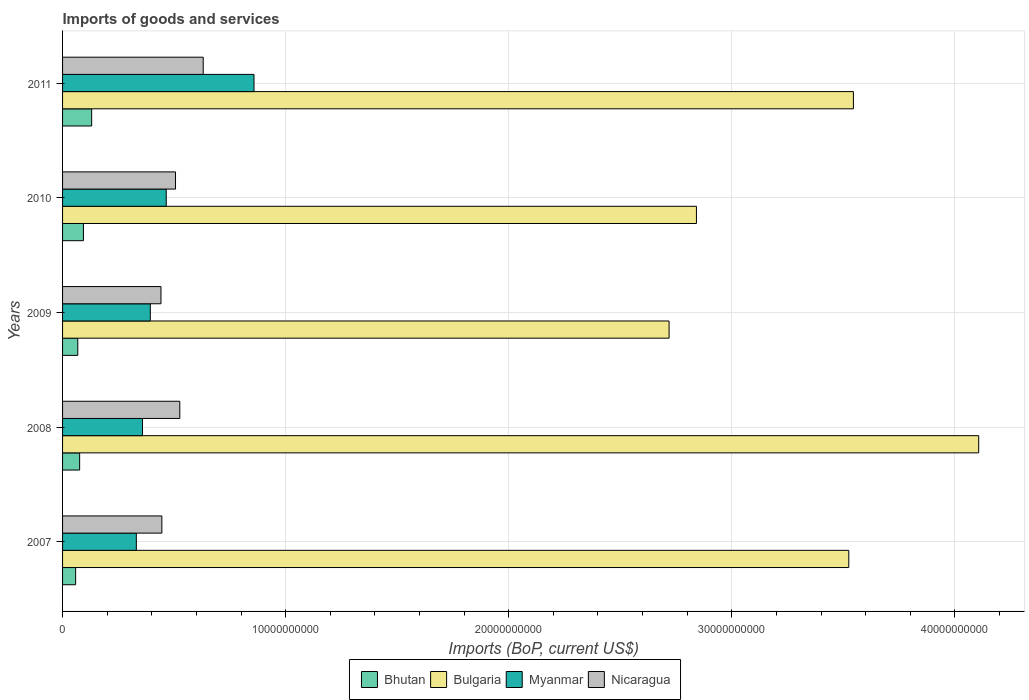Are the number of bars on each tick of the Y-axis equal?
Your response must be concise. Yes. How many bars are there on the 4th tick from the top?
Your response must be concise. 4. How many bars are there on the 5th tick from the bottom?
Your response must be concise. 4. What is the label of the 3rd group of bars from the top?
Your answer should be very brief. 2009. In how many cases, is the number of bars for a given year not equal to the number of legend labels?
Ensure brevity in your answer.  0. What is the amount spent on imports in Myanmar in 2009?
Ensure brevity in your answer.  3.93e+09. Across all years, what is the maximum amount spent on imports in Myanmar?
Your answer should be very brief. 8.58e+09. Across all years, what is the minimum amount spent on imports in Myanmar?
Keep it short and to the point. 3.31e+09. In which year was the amount spent on imports in Bhutan maximum?
Ensure brevity in your answer.  2011. What is the total amount spent on imports in Bhutan in the graph?
Give a very brief answer. 4.27e+09. What is the difference between the amount spent on imports in Bulgaria in 2007 and that in 2011?
Give a very brief answer. -2.08e+08. What is the difference between the amount spent on imports in Myanmar in 2010 and the amount spent on imports in Bhutan in 2011?
Your answer should be very brief. 3.34e+09. What is the average amount spent on imports in Bhutan per year?
Ensure brevity in your answer.  8.55e+08. In the year 2010, what is the difference between the amount spent on imports in Bulgaria and amount spent on imports in Bhutan?
Give a very brief answer. 2.75e+1. What is the ratio of the amount spent on imports in Myanmar in 2008 to that in 2009?
Your answer should be compact. 0.91. Is the amount spent on imports in Nicaragua in 2008 less than that in 2011?
Provide a succinct answer. Yes. Is the difference between the amount spent on imports in Bulgaria in 2009 and 2010 greater than the difference between the amount spent on imports in Bhutan in 2009 and 2010?
Offer a terse response. No. What is the difference between the highest and the second highest amount spent on imports in Myanmar?
Your answer should be very brief. 3.93e+09. What is the difference between the highest and the lowest amount spent on imports in Nicaragua?
Offer a terse response. 1.89e+09. Is it the case that in every year, the sum of the amount spent on imports in Bhutan and amount spent on imports in Bulgaria is greater than the sum of amount spent on imports in Myanmar and amount spent on imports in Nicaragua?
Your response must be concise. Yes. What does the 4th bar from the top in 2009 represents?
Provide a short and direct response. Bhutan. Is it the case that in every year, the sum of the amount spent on imports in Nicaragua and amount spent on imports in Bhutan is greater than the amount spent on imports in Myanmar?
Offer a very short reply. No. How many bars are there?
Your answer should be compact. 20. Are all the bars in the graph horizontal?
Your answer should be compact. Yes. How many years are there in the graph?
Make the answer very short. 5. Are the values on the major ticks of X-axis written in scientific E-notation?
Provide a short and direct response. No. What is the title of the graph?
Make the answer very short. Imports of goods and services. Does "Algeria" appear as one of the legend labels in the graph?
Your response must be concise. No. What is the label or title of the X-axis?
Provide a short and direct response. Imports (BoP, current US$). What is the Imports (BoP, current US$) of Bhutan in 2007?
Your response must be concise. 5.86e+08. What is the Imports (BoP, current US$) of Bulgaria in 2007?
Provide a succinct answer. 3.52e+1. What is the Imports (BoP, current US$) in Myanmar in 2007?
Give a very brief answer. 3.31e+09. What is the Imports (BoP, current US$) in Nicaragua in 2007?
Your answer should be very brief. 4.45e+09. What is the Imports (BoP, current US$) of Bhutan in 2008?
Give a very brief answer. 7.66e+08. What is the Imports (BoP, current US$) of Bulgaria in 2008?
Your answer should be compact. 4.11e+1. What is the Imports (BoP, current US$) of Myanmar in 2008?
Provide a succinct answer. 3.58e+09. What is the Imports (BoP, current US$) of Nicaragua in 2008?
Your answer should be very brief. 5.26e+09. What is the Imports (BoP, current US$) in Bhutan in 2009?
Your response must be concise. 6.82e+08. What is the Imports (BoP, current US$) in Bulgaria in 2009?
Offer a very short reply. 2.72e+1. What is the Imports (BoP, current US$) in Myanmar in 2009?
Give a very brief answer. 3.93e+09. What is the Imports (BoP, current US$) of Nicaragua in 2009?
Make the answer very short. 4.41e+09. What is the Imports (BoP, current US$) in Bhutan in 2010?
Offer a very short reply. 9.35e+08. What is the Imports (BoP, current US$) of Bulgaria in 2010?
Give a very brief answer. 2.84e+1. What is the Imports (BoP, current US$) of Myanmar in 2010?
Keep it short and to the point. 4.65e+09. What is the Imports (BoP, current US$) in Nicaragua in 2010?
Your answer should be compact. 5.06e+09. What is the Imports (BoP, current US$) of Bhutan in 2011?
Provide a short and direct response. 1.30e+09. What is the Imports (BoP, current US$) in Bulgaria in 2011?
Your answer should be very brief. 3.55e+1. What is the Imports (BoP, current US$) in Myanmar in 2011?
Offer a terse response. 8.58e+09. What is the Imports (BoP, current US$) in Nicaragua in 2011?
Your answer should be compact. 6.30e+09. Across all years, what is the maximum Imports (BoP, current US$) in Bhutan?
Keep it short and to the point. 1.30e+09. Across all years, what is the maximum Imports (BoP, current US$) of Bulgaria?
Your answer should be compact. 4.11e+1. Across all years, what is the maximum Imports (BoP, current US$) of Myanmar?
Your response must be concise. 8.58e+09. Across all years, what is the maximum Imports (BoP, current US$) of Nicaragua?
Your response must be concise. 6.30e+09. Across all years, what is the minimum Imports (BoP, current US$) in Bhutan?
Make the answer very short. 5.86e+08. Across all years, what is the minimum Imports (BoP, current US$) in Bulgaria?
Ensure brevity in your answer.  2.72e+1. Across all years, what is the minimum Imports (BoP, current US$) of Myanmar?
Provide a short and direct response. 3.31e+09. Across all years, what is the minimum Imports (BoP, current US$) of Nicaragua?
Offer a terse response. 4.41e+09. What is the total Imports (BoP, current US$) in Bhutan in the graph?
Provide a short and direct response. 4.27e+09. What is the total Imports (BoP, current US$) in Bulgaria in the graph?
Provide a short and direct response. 1.67e+11. What is the total Imports (BoP, current US$) in Myanmar in the graph?
Ensure brevity in your answer.  2.40e+1. What is the total Imports (BoP, current US$) of Nicaragua in the graph?
Your response must be concise. 2.55e+1. What is the difference between the Imports (BoP, current US$) in Bhutan in 2007 and that in 2008?
Provide a succinct answer. -1.79e+08. What is the difference between the Imports (BoP, current US$) of Bulgaria in 2007 and that in 2008?
Your response must be concise. -5.82e+09. What is the difference between the Imports (BoP, current US$) of Myanmar in 2007 and that in 2008?
Your answer should be very brief. -2.76e+08. What is the difference between the Imports (BoP, current US$) in Nicaragua in 2007 and that in 2008?
Make the answer very short. -8.05e+08. What is the difference between the Imports (BoP, current US$) of Bhutan in 2007 and that in 2009?
Offer a very short reply. -9.58e+07. What is the difference between the Imports (BoP, current US$) in Bulgaria in 2007 and that in 2009?
Provide a succinct answer. 8.06e+09. What is the difference between the Imports (BoP, current US$) in Myanmar in 2007 and that in 2009?
Keep it short and to the point. -6.26e+08. What is the difference between the Imports (BoP, current US$) of Nicaragua in 2007 and that in 2009?
Your answer should be compact. 3.97e+07. What is the difference between the Imports (BoP, current US$) in Bhutan in 2007 and that in 2010?
Ensure brevity in your answer.  -3.49e+08. What is the difference between the Imports (BoP, current US$) of Bulgaria in 2007 and that in 2010?
Your response must be concise. 6.83e+09. What is the difference between the Imports (BoP, current US$) of Myanmar in 2007 and that in 2010?
Make the answer very short. -1.34e+09. What is the difference between the Imports (BoP, current US$) in Nicaragua in 2007 and that in 2010?
Give a very brief answer. -6.12e+08. What is the difference between the Imports (BoP, current US$) in Bhutan in 2007 and that in 2011?
Offer a very short reply. -7.18e+08. What is the difference between the Imports (BoP, current US$) in Bulgaria in 2007 and that in 2011?
Make the answer very short. -2.08e+08. What is the difference between the Imports (BoP, current US$) of Myanmar in 2007 and that in 2011?
Your answer should be compact. -5.27e+09. What is the difference between the Imports (BoP, current US$) of Nicaragua in 2007 and that in 2011?
Provide a short and direct response. -1.85e+09. What is the difference between the Imports (BoP, current US$) in Bhutan in 2008 and that in 2009?
Your answer should be compact. 8.35e+07. What is the difference between the Imports (BoP, current US$) in Bulgaria in 2008 and that in 2009?
Your answer should be compact. 1.39e+1. What is the difference between the Imports (BoP, current US$) of Myanmar in 2008 and that in 2009?
Provide a short and direct response. -3.50e+08. What is the difference between the Imports (BoP, current US$) in Nicaragua in 2008 and that in 2009?
Make the answer very short. 8.44e+08. What is the difference between the Imports (BoP, current US$) of Bhutan in 2008 and that in 2010?
Make the answer very short. -1.70e+08. What is the difference between the Imports (BoP, current US$) of Bulgaria in 2008 and that in 2010?
Give a very brief answer. 1.27e+1. What is the difference between the Imports (BoP, current US$) in Myanmar in 2008 and that in 2010?
Your answer should be compact. -1.06e+09. What is the difference between the Imports (BoP, current US$) of Nicaragua in 2008 and that in 2010?
Offer a terse response. 1.92e+08. What is the difference between the Imports (BoP, current US$) of Bhutan in 2008 and that in 2011?
Ensure brevity in your answer.  -5.39e+08. What is the difference between the Imports (BoP, current US$) of Bulgaria in 2008 and that in 2011?
Your response must be concise. 5.61e+09. What is the difference between the Imports (BoP, current US$) in Myanmar in 2008 and that in 2011?
Your answer should be compact. -5.00e+09. What is the difference between the Imports (BoP, current US$) in Nicaragua in 2008 and that in 2011?
Make the answer very short. -1.05e+09. What is the difference between the Imports (BoP, current US$) in Bhutan in 2009 and that in 2010?
Provide a succinct answer. -2.53e+08. What is the difference between the Imports (BoP, current US$) in Bulgaria in 2009 and that in 2010?
Offer a terse response. -1.23e+09. What is the difference between the Imports (BoP, current US$) of Myanmar in 2009 and that in 2010?
Provide a succinct answer. -7.14e+08. What is the difference between the Imports (BoP, current US$) of Nicaragua in 2009 and that in 2010?
Your response must be concise. -6.52e+08. What is the difference between the Imports (BoP, current US$) in Bhutan in 2009 and that in 2011?
Provide a short and direct response. -6.22e+08. What is the difference between the Imports (BoP, current US$) of Bulgaria in 2009 and that in 2011?
Ensure brevity in your answer.  -8.26e+09. What is the difference between the Imports (BoP, current US$) of Myanmar in 2009 and that in 2011?
Provide a short and direct response. -4.65e+09. What is the difference between the Imports (BoP, current US$) of Nicaragua in 2009 and that in 2011?
Keep it short and to the point. -1.89e+09. What is the difference between the Imports (BoP, current US$) of Bhutan in 2010 and that in 2011?
Your answer should be compact. -3.69e+08. What is the difference between the Imports (BoP, current US$) of Bulgaria in 2010 and that in 2011?
Make the answer very short. -7.04e+09. What is the difference between the Imports (BoP, current US$) in Myanmar in 2010 and that in 2011?
Make the answer very short. -3.93e+09. What is the difference between the Imports (BoP, current US$) in Nicaragua in 2010 and that in 2011?
Make the answer very short. -1.24e+09. What is the difference between the Imports (BoP, current US$) in Bhutan in 2007 and the Imports (BoP, current US$) in Bulgaria in 2008?
Offer a very short reply. -4.05e+1. What is the difference between the Imports (BoP, current US$) of Bhutan in 2007 and the Imports (BoP, current US$) of Myanmar in 2008?
Provide a succinct answer. -3.00e+09. What is the difference between the Imports (BoP, current US$) in Bhutan in 2007 and the Imports (BoP, current US$) in Nicaragua in 2008?
Give a very brief answer. -4.67e+09. What is the difference between the Imports (BoP, current US$) of Bulgaria in 2007 and the Imports (BoP, current US$) of Myanmar in 2008?
Your response must be concise. 3.17e+1. What is the difference between the Imports (BoP, current US$) in Bulgaria in 2007 and the Imports (BoP, current US$) in Nicaragua in 2008?
Your answer should be very brief. 3.00e+1. What is the difference between the Imports (BoP, current US$) of Myanmar in 2007 and the Imports (BoP, current US$) of Nicaragua in 2008?
Offer a terse response. -1.95e+09. What is the difference between the Imports (BoP, current US$) of Bhutan in 2007 and the Imports (BoP, current US$) of Bulgaria in 2009?
Ensure brevity in your answer.  -2.66e+1. What is the difference between the Imports (BoP, current US$) of Bhutan in 2007 and the Imports (BoP, current US$) of Myanmar in 2009?
Keep it short and to the point. -3.35e+09. What is the difference between the Imports (BoP, current US$) of Bhutan in 2007 and the Imports (BoP, current US$) of Nicaragua in 2009?
Your answer should be compact. -3.82e+09. What is the difference between the Imports (BoP, current US$) of Bulgaria in 2007 and the Imports (BoP, current US$) of Myanmar in 2009?
Keep it short and to the point. 3.13e+1. What is the difference between the Imports (BoP, current US$) in Bulgaria in 2007 and the Imports (BoP, current US$) in Nicaragua in 2009?
Offer a terse response. 3.08e+1. What is the difference between the Imports (BoP, current US$) in Myanmar in 2007 and the Imports (BoP, current US$) in Nicaragua in 2009?
Your answer should be compact. -1.10e+09. What is the difference between the Imports (BoP, current US$) in Bhutan in 2007 and the Imports (BoP, current US$) in Bulgaria in 2010?
Your answer should be very brief. -2.78e+1. What is the difference between the Imports (BoP, current US$) of Bhutan in 2007 and the Imports (BoP, current US$) of Myanmar in 2010?
Offer a terse response. -4.06e+09. What is the difference between the Imports (BoP, current US$) in Bhutan in 2007 and the Imports (BoP, current US$) in Nicaragua in 2010?
Give a very brief answer. -4.48e+09. What is the difference between the Imports (BoP, current US$) of Bulgaria in 2007 and the Imports (BoP, current US$) of Myanmar in 2010?
Make the answer very short. 3.06e+1. What is the difference between the Imports (BoP, current US$) of Bulgaria in 2007 and the Imports (BoP, current US$) of Nicaragua in 2010?
Offer a very short reply. 3.02e+1. What is the difference between the Imports (BoP, current US$) in Myanmar in 2007 and the Imports (BoP, current US$) in Nicaragua in 2010?
Provide a short and direct response. -1.76e+09. What is the difference between the Imports (BoP, current US$) in Bhutan in 2007 and the Imports (BoP, current US$) in Bulgaria in 2011?
Make the answer very short. -3.49e+1. What is the difference between the Imports (BoP, current US$) in Bhutan in 2007 and the Imports (BoP, current US$) in Myanmar in 2011?
Your answer should be very brief. -7.99e+09. What is the difference between the Imports (BoP, current US$) in Bhutan in 2007 and the Imports (BoP, current US$) in Nicaragua in 2011?
Provide a succinct answer. -5.72e+09. What is the difference between the Imports (BoP, current US$) in Bulgaria in 2007 and the Imports (BoP, current US$) in Myanmar in 2011?
Keep it short and to the point. 2.67e+1. What is the difference between the Imports (BoP, current US$) in Bulgaria in 2007 and the Imports (BoP, current US$) in Nicaragua in 2011?
Provide a short and direct response. 2.89e+1. What is the difference between the Imports (BoP, current US$) of Myanmar in 2007 and the Imports (BoP, current US$) of Nicaragua in 2011?
Provide a succinct answer. -3.00e+09. What is the difference between the Imports (BoP, current US$) in Bhutan in 2008 and the Imports (BoP, current US$) in Bulgaria in 2009?
Provide a short and direct response. -2.64e+1. What is the difference between the Imports (BoP, current US$) of Bhutan in 2008 and the Imports (BoP, current US$) of Myanmar in 2009?
Provide a short and direct response. -3.17e+09. What is the difference between the Imports (BoP, current US$) of Bhutan in 2008 and the Imports (BoP, current US$) of Nicaragua in 2009?
Your answer should be compact. -3.65e+09. What is the difference between the Imports (BoP, current US$) in Bulgaria in 2008 and the Imports (BoP, current US$) in Myanmar in 2009?
Your response must be concise. 3.71e+1. What is the difference between the Imports (BoP, current US$) of Bulgaria in 2008 and the Imports (BoP, current US$) of Nicaragua in 2009?
Make the answer very short. 3.67e+1. What is the difference between the Imports (BoP, current US$) of Myanmar in 2008 and the Imports (BoP, current US$) of Nicaragua in 2009?
Ensure brevity in your answer.  -8.28e+08. What is the difference between the Imports (BoP, current US$) of Bhutan in 2008 and the Imports (BoP, current US$) of Bulgaria in 2010?
Make the answer very short. -2.76e+1. What is the difference between the Imports (BoP, current US$) in Bhutan in 2008 and the Imports (BoP, current US$) in Myanmar in 2010?
Provide a succinct answer. -3.88e+09. What is the difference between the Imports (BoP, current US$) of Bhutan in 2008 and the Imports (BoP, current US$) of Nicaragua in 2010?
Ensure brevity in your answer.  -4.30e+09. What is the difference between the Imports (BoP, current US$) of Bulgaria in 2008 and the Imports (BoP, current US$) of Myanmar in 2010?
Offer a terse response. 3.64e+1. What is the difference between the Imports (BoP, current US$) of Bulgaria in 2008 and the Imports (BoP, current US$) of Nicaragua in 2010?
Keep it short and to the point. 3.60e+1. What is the difference between the Imports (BoP, current US$) in Myanmar in 2008 and the Imports (BoP, current US$) in Nicaragua in 2010?
Your response must be concise. -1.48e+09. What is the difference between the Imports (BoP, current US$) in Bhutan in 2008 and the Imports (BoP, current US$) in Bulgaria in 2011?
Give a very brief answer. -3.47e+1. What is the difference between the Imports (BoP, current US$) of Bhutan in 2008 and the Imports (BoP, current US$) of Myanmar in 2011?
Offer a terse response. -7.82e+09. What is the difference between the Imports (BoP, current US$) in Bhutan in 2008 and the Imports (BoP, current US$) in Nicaragua in 2011?
Your response must be concise. -5.54e+09. What is the difference between the Imports (BoP, current US$) in Bulgaria in 2008 and the Imports (BoP, current US$) in Myanmar in 2011?
Your answer should be very brief. 3.25e+1. What is the difference between the Imports (BoP, current US$) in Bulgaria in 2008 and the Imports (BoP, current US$) in Nicaragua in 2011?
Give a very brief answer. 3.48e+1. What is the difference between the Imports (BoP, current US$) in Myanmar in 2008 and the Imports (BoP, current US$) in Nicaragua in 2011?
Your answer should be compact. -2.72e+09. What is the difference between the Imports (BoP, current US$) in Bhutan in 2009 and the Imports (BoP, current US$) in Bulgaria in 2010?
Your response must be concise. -2.77e+1. What is the difference between the Imports (BoP, current US$) of Bhutan in 2009 and the Imports (BoP, current US$) of Myanmar in 2010?
Provide a succinct answer. -3.96e+09. What is the difference between the Imports (BoP, current US$) in Bhutan in 2009 and the Imports (BoP, current US$) in Nicaragua in 2010?
Your answer should be compact. -4.38e+09. What is the difference between the Imports (BoP, current US$) of Bulgaria in 2009 and the Imports (BoP, current US$) of Myanmar in 2010?
Your answer should be compact. 2.25e+1. What is the difference between the Imports (BoP, current US$) of Bulgaria in 2009 and the Imports (BoP, current US$) of Nicaragua in 2010?
Keep it short and to the point. 2.21e+1. What is the difference between the Imports (BoP, current US$) in Myanmar in 2009 and the Imports (BoP, current US$) in Nicaragua in 2010?
Make the answer very short. -1.13e+09. What is the difference between the Imports (BoP, current US$) in Bhutan in 2009 and the Imports (BoP, current US$) in Bulgaria in 2011?
Give a very brief answer. -3.48e+1. What is the difference between the Imports (BoP, current US$) of Bhutan in 2009 and the Imports (BoP, current US$) of Myanmar in 2011?
Provide a succinct answer. -7.90e+09. What is the difference between the Imports (BoP, current US$) in Bhutan in 2009 and the Imports (BoP, current US$) in Nicaragua in 2011?
Keep it short and to the point. -5.62e+09. What is the difference between the Imports (BoP, current US$) in Bulgaria in 2009 and the Imports (BoP, current US$) in Myanmar in 2011?
Keep it short and to the point. 1.86e+1. What is the difference between the Imports (BoP, current US$) of Bulgaria in 2009 and the Imports (BoP, current US$) of Nicaragua in 2011?
Provide a short and direct response. 2.09e+1. What is the difference between the Imports (BoP, current US$) in Myanmar in 2009 and the Imports (BoP, current US$) in Nicaragua in 2011?
Offer a very short reply. -2.37e+09. What is the difference between the Imports (BoP, current US$) in Bhutan in 2010 and the Imports (BoP, current US$) in Bulgaria in 2011?
Give a very brief answer. -3.45e+1. What is the difference between the Imports (BoP, current US$) in Bhutan in 2010 and the Imports (BoP, current US$) in Myanmar in 2011?
Offer a terse response. -7.65e+09. What is the difference between the Imports (BoP, current US$) in Bhutan in 2010 and the Imports (BoP, current US$) in Nicaragua in 2011?
Your answer should be compact. -5.37e+09. What is the difference between the Imports (BoP, current US$) in Bulgaria in 2010 and the Imports (BoP, current US$) in Myanmar in 2011?
Provide a succinct answer. 1.98e+1. What is the difference between the Imports (BoP, current US$) in Bulgaria in 2010 and the Imports (BoP, current US$) in Nicaragua in 2011?
Keep it short and to the point. 2.21e+1. What is the difference between the Imports (BoP, current US$) of Myanmar in 2010 and the Imports (BoP, current US$) of Nicaragua in 2011?
Your response must be concise. -1.66e+09. What is the average Imports (BoP, current US$) of Bhutan per year?
Your answer should be very brief. 8.55e+08. What is the average Imports (BoP, current US$) in Bulgaria per year?
Your response must be concise. 3.35e+1. What is the average Imports (BoP, current US$) in Myanmar per year?
Make the answer very short. 4.81e+09. What is the average Imports (BoP, current US$) of Nicaragua per year?
Your response must be concise. 5.10e+09. In the year 2007, what is the difference between the Imports (BoP, current US$) of Bhutan and Imports (BoP, current US$) of Bulgaria?
Your answer should be compact. -3.47e+1. In the year 2007, what is the difference between the Imports (BoP, current US$) in Bhutan and Imports (BoP, current US$) in Myanmar?
Offer a very short reply. -2.72e+09. In the year 2007, what is the difference between the Imports (BoP, current US$) of Bhutan and Imports (BoP, current US$) of Nicaragua?
Your answer should be very brief. -3.86e+09. In the year 2007, what is the difference between the Imports (BoP, current US$) in Bulgaria and Imports (BoP, current US$) in Myanmar?
Your response must be concise. 3.19e+1. In the year 2007, what is the difference between the Imports (BoP, current US$) in Bulgaria and Imports (BoP, current US$) in Nicaragua?
Make the answer very short. 3.08e+1. In the year 2007, what is the difference between the Imports (BoP, current US$) of Myanmar and Imports (BoP, current US$) of Nicaragua?
Ensure brevity in your answer.  -1.14e+09. In the year 2008, what is the difference between the Imports (BoP, current US$) of Bhutan and Imports (BoP, current US$) of Bulgaria?
Ensure brevity in your answer.  -4.03e+1. In the year 2008, what is the difference between the Imports (BoP, current US$) in Bhutan and Imports (BoP, current US$) in Myanmar?
Your answer should be very brief. -2.82e+09. In the year 2008, what is the difference between the Imports (BoP, current US$) of Bhutan and Imports (BoP, current US$) of Nicaragua?
Offer a terse response. -4.49e+09. In the year 2008, what is the difference between the Imports (BoP, current US$) of Bulgaria and Imports (BoP, current US$) of Myanmar?
Provide a short and direct response. 3.75e+1. In the year 2008, what is the difference between the Imports (BoP, current US$) in Bulgaria and Imports (BoP, current US$) in Nicaragua?
Offer a terse response. 3.58e+1. In the year 2008, what is the difference between the Imports (BoP, current US$) in Myanmar and Imports (BoP, current US$) in Nicaragua?
Offer a terse response. -1.67e+09. In the year 2009, what is the difference between the Imports (BoP, current US$) of Bhutan and Imports (BoP, current US$) of Bulgaria?
Provide a succinct answer. -2.65e+1. In the year 2009, what is the difference between the Imports (BoP, current US$) in Bhutan and Imports (BoP, current US$) in Myanmar?
Your answer should be very brief. -3.25e+09. In the year 2009, what is the difference between the Imports (BoP, current US$) of Bhutan and Imports (BoP, current US$) of Nicaragua?
Your answer should be very brief. -3.73e+09. In the year 2009, what is the difference between the Imports (BoP, current US$) in Bulgaria and Imports (BoP, current US$) in Myanmar?
Make the answer very short. 2.33e+1. In the year 2009, what is the difference between the Imports (BoP, current US$) in Bulgaria and Imports (BoP, current US$) in Nicaragua?
Ensure brevity in your answer.  2.28e+1. In the year 2009, what is the difference between the Imports (BoP, current US$) in Myanmar and Imports (BoP, current US$) in Nicaragua?
Offer a terse response. -4.78e+08. In the year 2010, what is the difference between the Imports (BoP, current US$) of Bhutan and Imports (BoP, current US$) of Bulgaria?
Make the answer very short. -2.75e+1. In the year 2010, what is the difference between the Imports (BoP, current US$) of Bhutan and Imports (BoP, current US$) of Myanmar?
Ensure brevity in your answer.  -3.71e+09. In the year 2010, what is the difference between the Imports (BoP, current US$) of Bhutan and Imports (BoP, current US$) of Nicaragua?
Offer a very short reply. -4.13e+09. In the year 2010, what is the difference between the Imports (BoP, current US$) in Bulgaria and Imports (BoP, current US$) in Myanmar?
Keep it short and to the point. 2.38e+1. In the year 2010, what is the difference between the Imports (BoP, current US$) in Bulgaria and Imports (BoP, current US$) in Nicaragua?
Provide a succinct answer. 2.34e+1. In the year 2010, what is the difference between the Imports (BoP, current US$) of Myanmar and Imports (BoP, current US$) of Nicaragua?
Your answer should be very brief. -4.16e+08. In the year 2011, what is the difference between the Imports (BoP, current US$) of Bhutan and Imports (BoP, current US$) of Bulgaria?
Offer a terse response. -3.41e+1. In the year 2011, what is the difference between the Imports (BoP, current US$) of Bhutan and Imports (BoP, current US$) of Myanmar?
Give a very brief answer. -7.28e+09. In the year 2011, what is the difference between the Imports (BoP, current US$) of Bhutan and Imports (BoP, current US$) of Nicaragua?
Provide a succinct answer. -5.00e+09. In the year 2011, what is the difference between the Imports (BoP, current US$) of Bulgaria and Imports (BoP, current US$) of Myanmar?
Offer a terse response. 2.69e+1. In the year 2011, what is the difference between the Imports (BoP, current US$) of Bulgaria and Imports (BoP, current US$) of Nicaragua?
Ensure brevity in your answer.  2.91e+1. In the year 2011, what is the difference between the Imports (BoP, current US$) of Myanmar and Imports (BoP, current US$) of Nicaragua?
Ensure brevity in your answer.  2.28e+09. What is the ratio of the Imports (BoP, current US$) in Bhutan in 2007 to that in 2008?
Make the answer very short. 0.77. What is the ratio of the Imports (BoP, current US$) of Bulgaria in 2007 to that in 2008?
Provide a succinct answer. 0.86. What is the ratio of the Imports (BoP, current US$) of Myanmar in 2007 to that in 2008?
Your answer should be compact. 0.92. What is the ratio of the Imports (BoP, current US$) in Nicaragua in 2007 to that in 2008?
Make the answer very short. 0.85. What is the ratio of the Imports (BoP, current US$) in Bhutan in 2007 to that in 2009?
Make the answer very short. 0.86. What is the ratio of the Imports (BoP, current US$) in Bulgaria in 2007 to that in 2009?
Your answer should be very brief. 1.3. What is the ratio of the Imports (BoP, current US$) of Myanmar in 2007 to that in 2009?
Your response must be concise. 0.84. What is the ratio of the Imports (BoP, current US$) in Nicaragua in 2007 to that in 2009?
Your response must be concise. 1.01. What is the ratio of the Imports (BoP, current US$) of Bhutan in 2007 to that in 2010?
Give a very brief answer. 0.63. What is the ratio of the Imports (BoP, current US$) in Bulgaria in 2007 to that in 2010?
Provide a short and direct response. 1.24. What is the ratio of the Imports (BoP, current US$) in Myanmar in 2007 to that in 2010?
Keep it short and to the point. 0.71. What is the ratio of the Imports (BoP, current US$) of Nicaragua in 2007 to that in 2010?
Your response must be concise. 0.88. What is the ratio of the Imports (BoP, current US$) in Bhutan in 2007 to that in 2011?
Ensure brevity in your answer.  0.45. What is the ratio of the Imports (BoP, current US$) in Bulgaria in 2007 to that in 2011?
Your response must be concise. 0.99. What is the ratio of the Imports (BoP, current US$) in Myanmar in 2007 to that in 2011?
Make the answer very short. 0.39. What is the ratio of the Imports (BoP, current US$) in Nicaragua in 2007 to that in 2011?
Your response must be concise. 0.71. What is the ratio of the Imports (BoP, current US$) in Bhutan in 2008 to that in 2009?
Your answer should be compact. 1.12. What is the ratio of the Imports (BoP, current US$) of Bulgaria in 2008 to that in 2009?
Provide a short and direct response. 1.51. What is the ratio of the Imports (BoP, current US$) of Myanmar in 2008 to that in 2009?
Provide a short and direct response. 0.91. What is the ratio of the Imports (BoP, current US$) in Nicaragua in 2008 to that in 2009?
Provide a short and direct response. 1.19. What is the ratio of the Imports (BoP, current US$) in Bhutan in 2008 to that in 2010?
Your answer should be very brief. 0.82. What is the ratio of the Imports (BoP, current US$) in Bulgaria in 2008 to that in 2010?
Provide a short and direct response. 1.45. What is the ratio of the Imports (BoP, current US$) of Myanmar in 2008 to that in 2010?
Keep it short and to the point. 0.77. What is the ratio of the Imports (BoP, current US$) in Nicaragua in 2008 to that in 2010?
Your response must be concise. 1.04. What is the ratio of the Imports (BoP, current US$) of Bhutan in 2008 to that in 2011?
Provide a succinct answer. 0.59. What is the ratio of the Imports (BoP, current US$) of Bulgaria in 2008 to that in 2011?
Provide a succinct answer. 1.16. What is the ratio of the Imports (BoP, current US$) of Myanmar in 2008 to that in 2011?
Ensure brevity in your answer.  0.42. What is the ratio of the Imports (BoP, current US$) of Nicaragua in 2008 to that in 2011?
Your response must be concise. 0.83. What is the ratio of the Imports (BoP, current US$) in Bhutan in 2009 to that in 2010?
Give a very brief answer. 0.73. What is the ratio of the Imports (BoP, current US$) of Bulgaria in 2009 to that in 2010?
Make the answer very short. 0.96. What is the ratio of the Imports (BoP, current US$) of Myanmar in 2009 to that in 2010?
Provide a short and direct response. 0.85. What is the ratio of the Imports (BoP, current US$) in Nicaragua in 2009 to that in 2010?
Keep it short and to the point. 0.87. What is the ratio of the Imports (BoP, current US$) of Bhutan in 2009 to that in 2011?
Your answer should be compact. 0.52. What is the ratio of the Imports (BoP, current US$) of Bulgaria in 2009 to that in 2011?
Provide a succinct answer. 0.77. What is the ratio of the Imports (BoP, current US$) of Myanmar in 2009 to that in 2011?
Your answer should be very brief. 0.46. What is the ratio of the Imports (BoP, current US$) in Nicaragua in 2009 to that in 2011?
Provide a short and direct response. 0.7. What is the ratio of the Imports (BoP, current US$) of Bhutan in 2010 to that in 2011?
Provide a succinct answer. 0.72. What is the ratio of the Imports (BoP, current US$) of Bulgaria in 2010 to that in 2011?
Your answer should be compact. 0.8. What is the ratio of the Imports (BoP, current US$) of Myanmar in 2010 to that in 2011?
Make the answer very short. 0.54. What is the ratio of the Imports (BoP, current US$) of Nicaragua in 2010 to that in 2011?
Provide a succinct answer. 0.8. What is the difference between the highest and the second highest Imports (BoP, current US$) in Bhutan?
Make the answer very short. 3.69e+08. What is the difference between the highest and the second highest Imports (BoP, current US$) of Bulgaria?
Your answer should be very brief. 5.61e+09. What is the difference between the highest and the second highest Imports (BoP, current US$) of Myanmar?
Your response must be concise. 3.93e+09. What is the difference between the highest and the second highest Imports (BoP, current US$) of Nicaragua?
Offer a terse response. 1.05e+09. What is the difference between the highest and the lowest Imports (BoP, current US$) of Bhutan?
Give a very brief answer. 7.18e+08. What is the difference between the highest and the lowest Imports (BoP, current US$) in Bulgaria?
Offer a very short reply. 1.39e+1. What is the difference between the highest and the lowest Imports (BoP, current US$) in Myanmar?
Ensure brevity in your answer.  5.27e+09. What is the difference between the highest and the lowest Imports (BoP, current US$) in Nicaragua?
Offer a very short reply. 1.89e+09. 